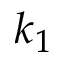Convert formula to latex. <formula><loc_0><loc_0><loc_500><loc_500>k _ { 1 }</formula> 